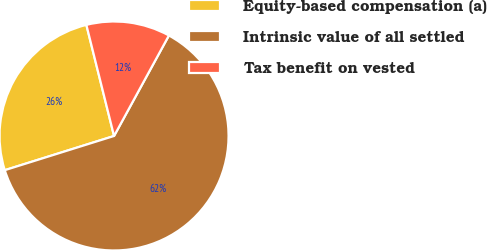Convert chart. <chart><loc_0><loc_0><loc_500><loc_500><pie_chart><fcel>Equity-based compensation (a)<fcel>Intrinsic value of all settled<fcel>Tax benefit on vested<nl><fcel>25.94%<fcel>62.22%<fcel>11.84%<nl></chart> 